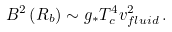Convert formula to latex. <formula><loc_0><loc_0><loc_500><loc_500>B ^ { 2 } \left ( R _ { b } \right ) \sim g _ { \ast } T _ { c } ^ { 4 } v _ { f l u i d } ^ { 2 } \, .</formula> 